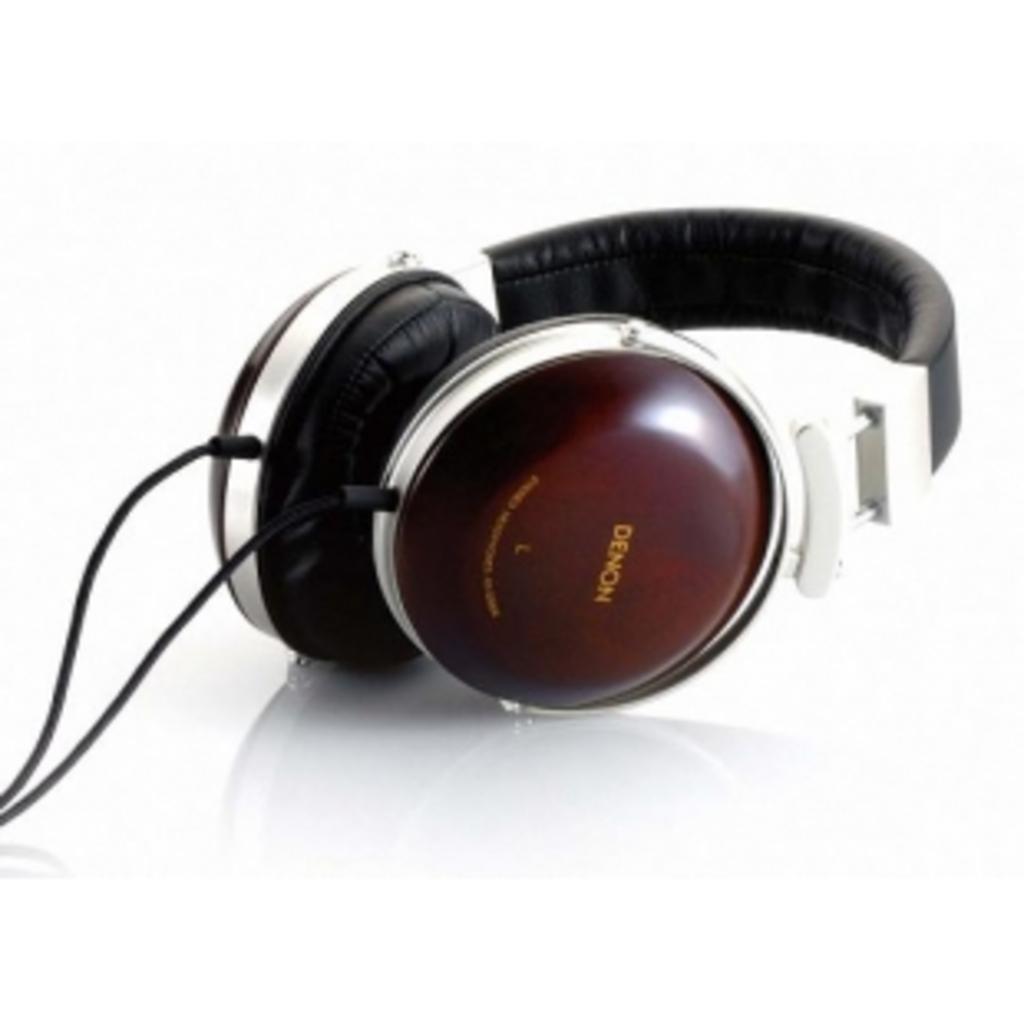How would you summarize this image in a sentence or two? This is a pair of headset. 